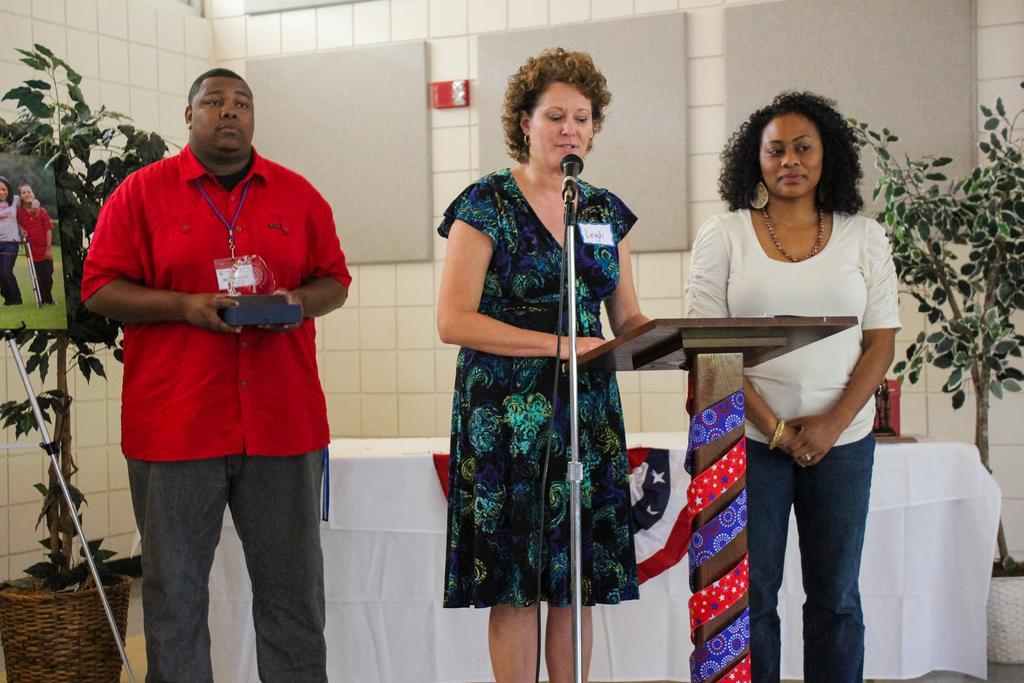In one or two sentences, can you explain what this image depicts? In this image I can see two women and a man are standing among them the man is holding an object in hands. Here I can see a microphone and a podium. In the background I can see plants, a wall and a table. The table is covered with white color cloth. 